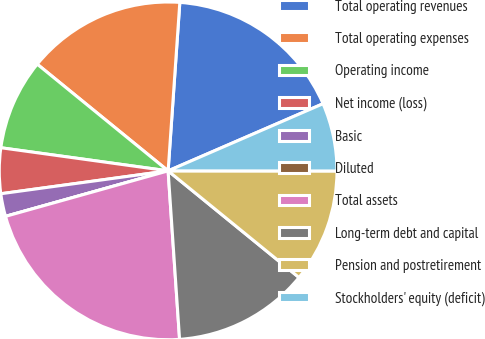Convert chart to OTSL. <chart><loc_0><loc_0><loc_500><loc_500><pie_chart><fcel>Total operating revenues<fcel>Total operating expenses<fcel>Operating income<fcel>Net income (loss)<fcel>Basic<fcel>Diluted<fcel>Total assets<fcel>Long-term debt and capital<fcel>Pension and postretirement<fcel>Stockholders' equity (deficit)<nl><fcel>17.39%<fcel>15.22%<fcel>8.7%<fcel>4.35%<fcel>2.18%<fcel>0.0%<fcel>21.74%<fcel>13.04%<fcel>10.87%<fcel>6.52%<nl></chart> 